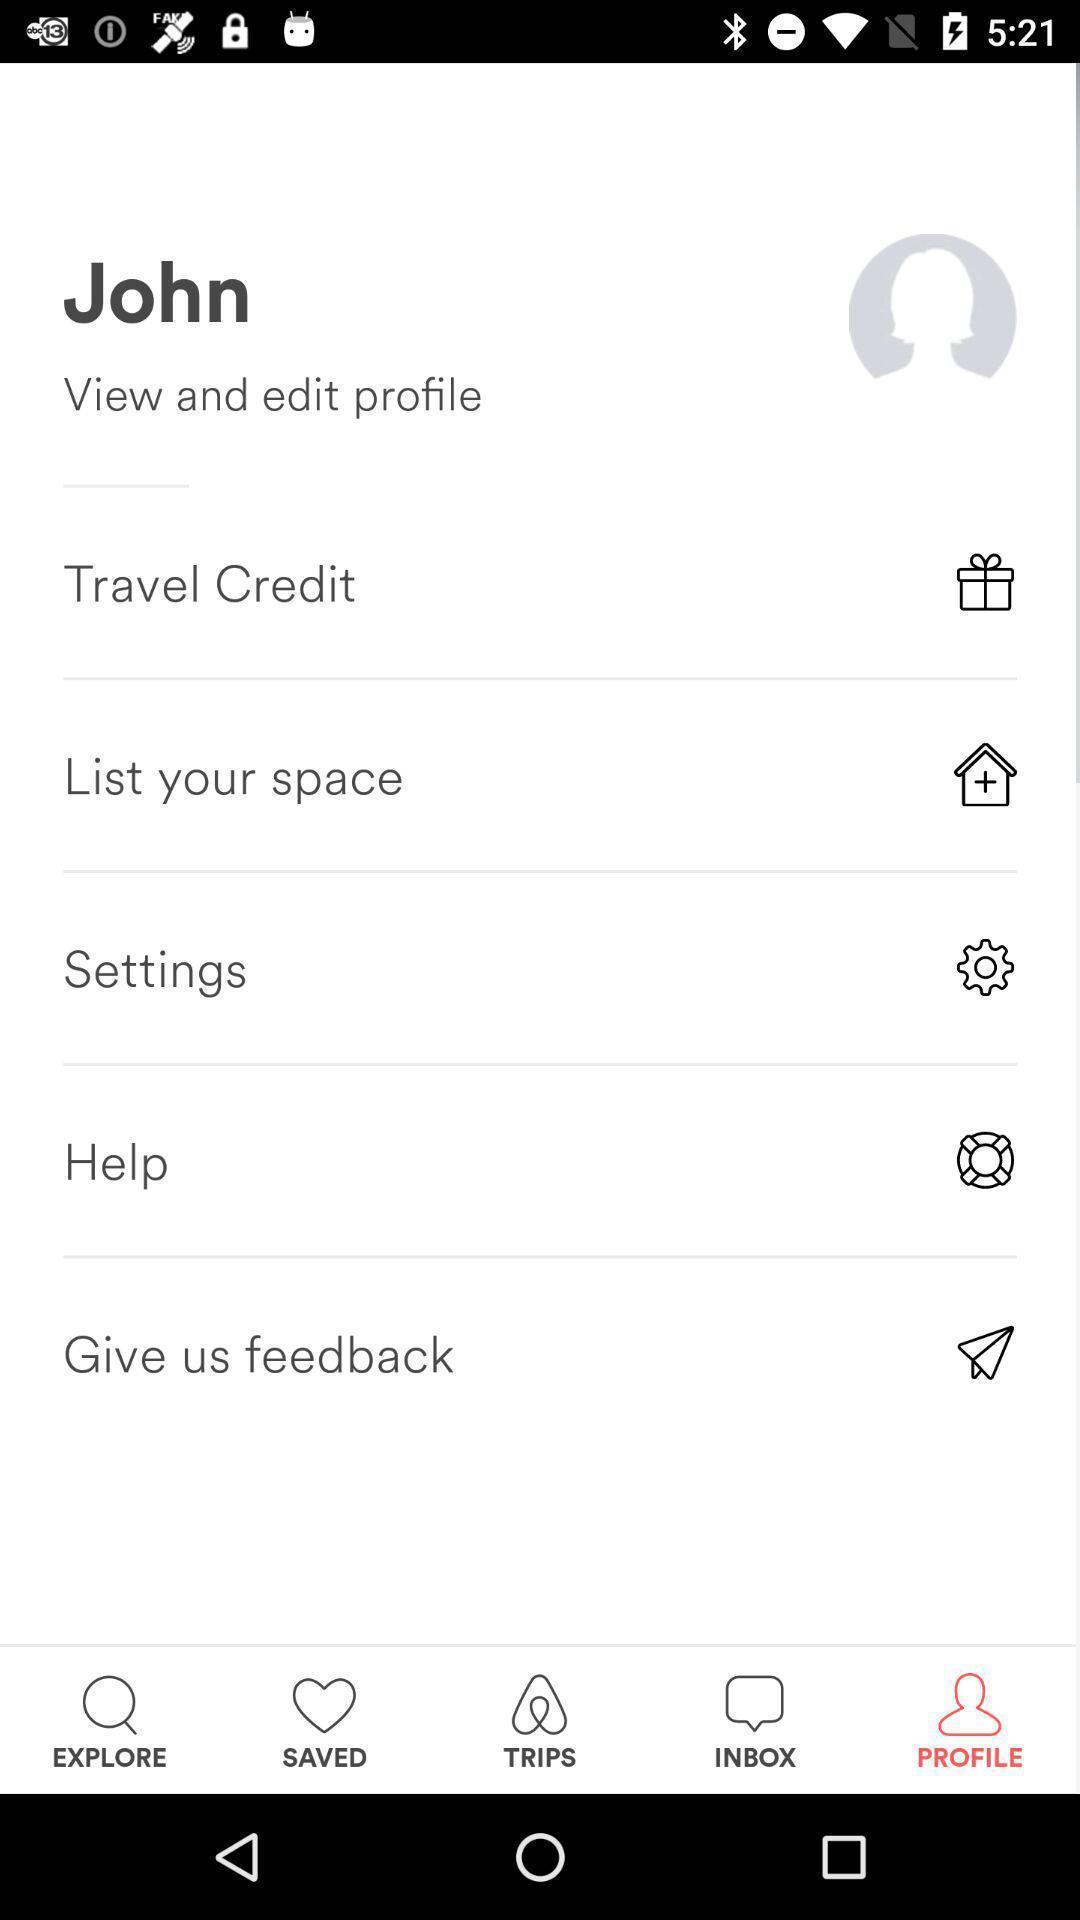Provide a textual representation of this image. Travelling application shows profile of a person. 